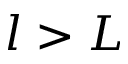Convert formula to latex. <formula><loc_0><loc_0><loc_500><loc_500>l > L</formula> 